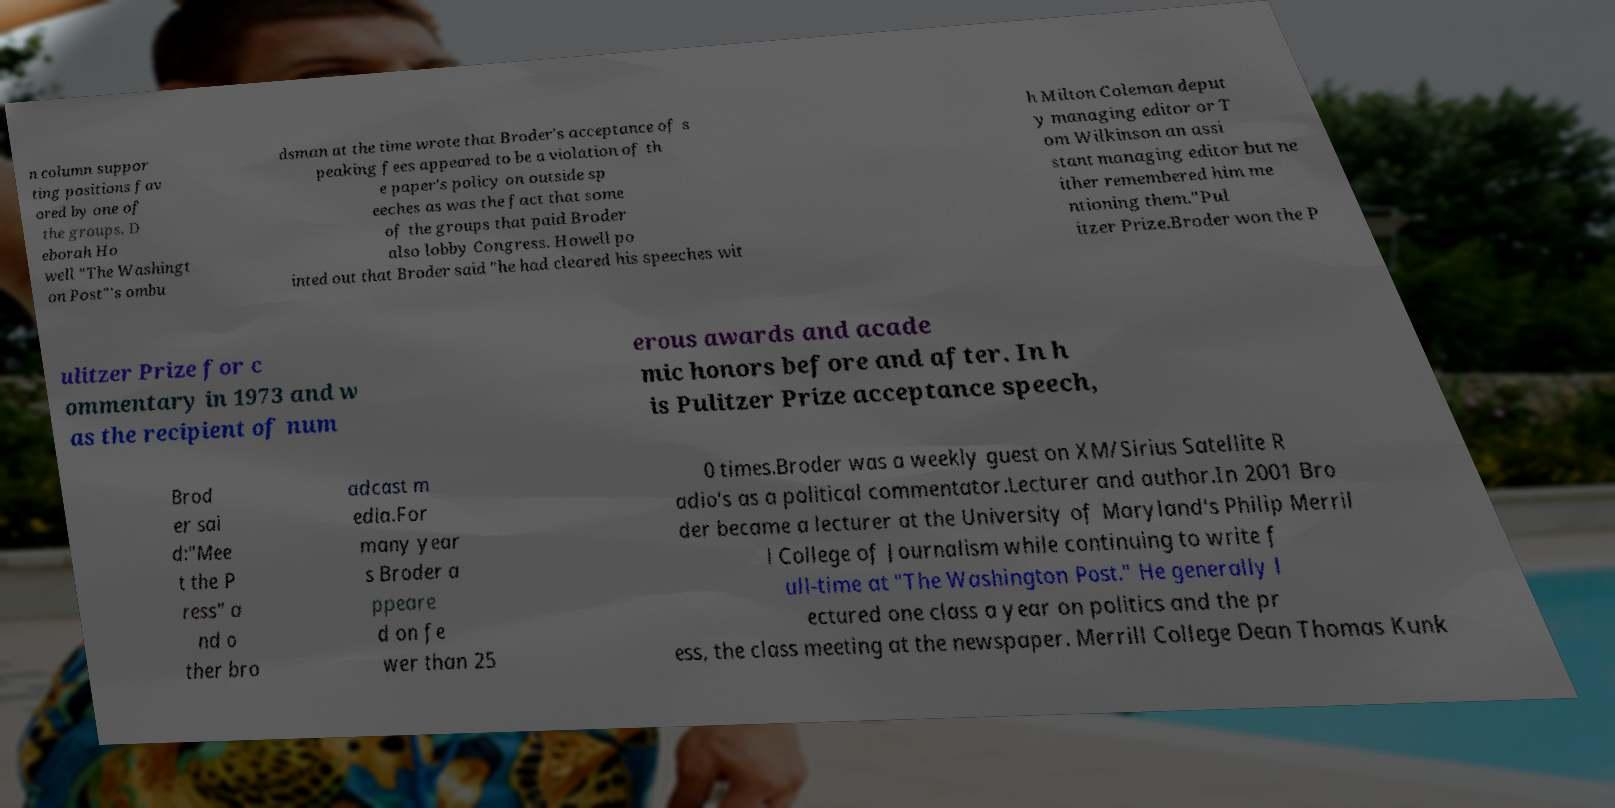Please identify and transcribe the text found in this image. n column suppor ting positions fav ored by one of the groups. D eborah Ho well "The Washingt on Post"'s ombu dsman at the time wrote that Broder's acceptance of s peaking fees appeared to be a violation of th e paper's policy on outside sp eeches as was the fact that some of the groups that paid Broder also lobby Congress. Howell po inted out that Broder said "he had cleared his speeches wit h Milton Coleman deput y managing editor or T om Wilkinson an assi stant managing editor but ne ither remembered him me ntioning them."Pul itzer Prize.Broder won the P ulitzer Prize for c ommentary in 1973 and w as the recipient of num erous awards and acade mic honors before and after. In h is Pulitzer Prize acceptance speech, Brod er sai d:"Mee t the P ress" a nd o ther bro adcast m edia.For many year s Broder a ppeare d on fe wer than 25 0 times.Broder was a weekly guest on XM/Sirius Satellite R adio's as a political commentator.Lecturer and author.In 2001 Bro der became a lecturer at the University of Maryland's Philip Merril l College of Journalism while continuing to write f ull-time at "The Washington Post." He generally l ectured one class a year on politics and the pr ess, the class meeting at the newspaper. Merrill College Dean Thomas Kunk 